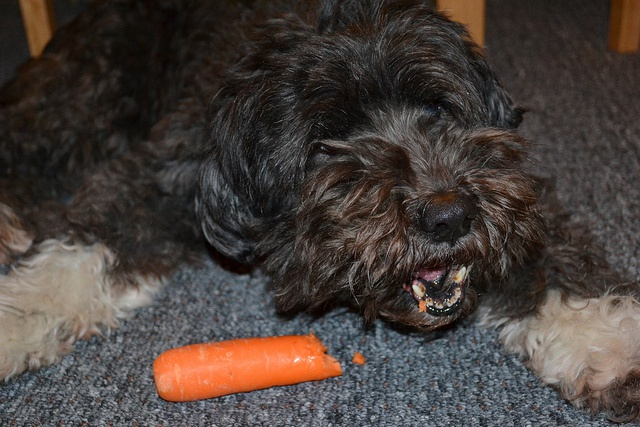Describe the objects in this image and their specific colors. I can see dog in black, gray, and darkgray tones and carrot in black, red, salmon, and brown tones in this image. 